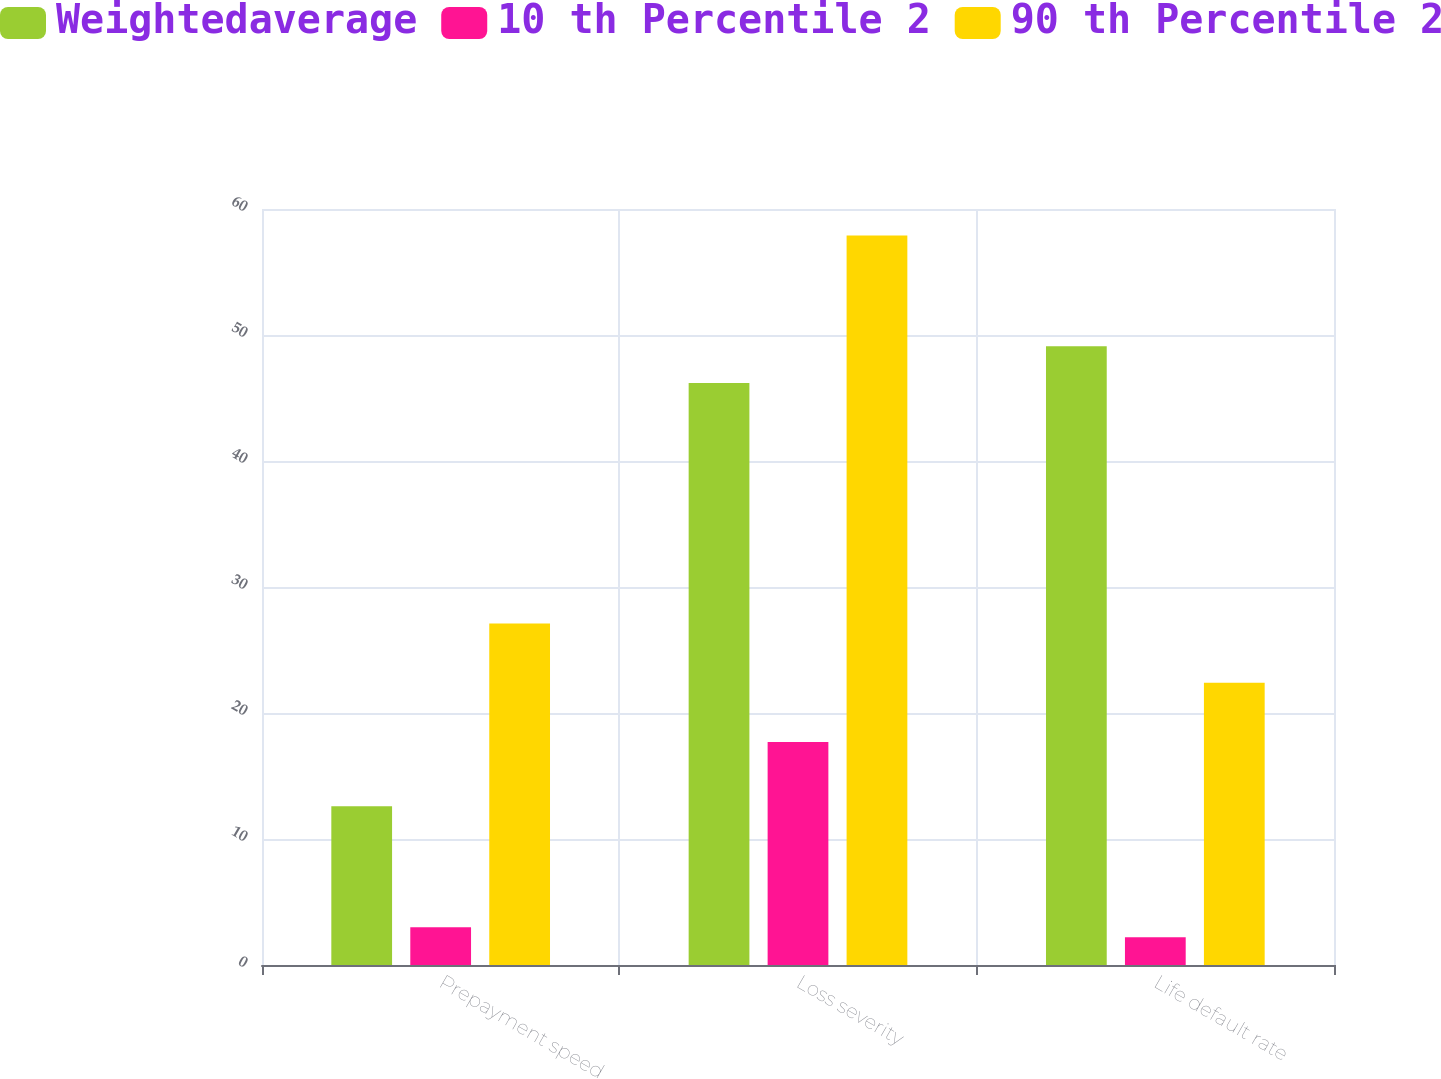Convert chart to OTSL. <chart><loc_0><loc_0><loc_500><loc_500><stacked_bar_chart><ecel><fcel>Prepayment speed<fcel>Loss severity<fcel>Life default rate<nl><fcel>Weightedaverage<fcel>12.6<fcel>46.2<fcel>49.1<nl><fcel>10 th Percentile 2<fcel>3<fcel>17.7<fcel>2.2<nl><fcel>90 th Percentile 2<fcel>27.1<fcel>57.9<fcel>22.4<nl></chart> 